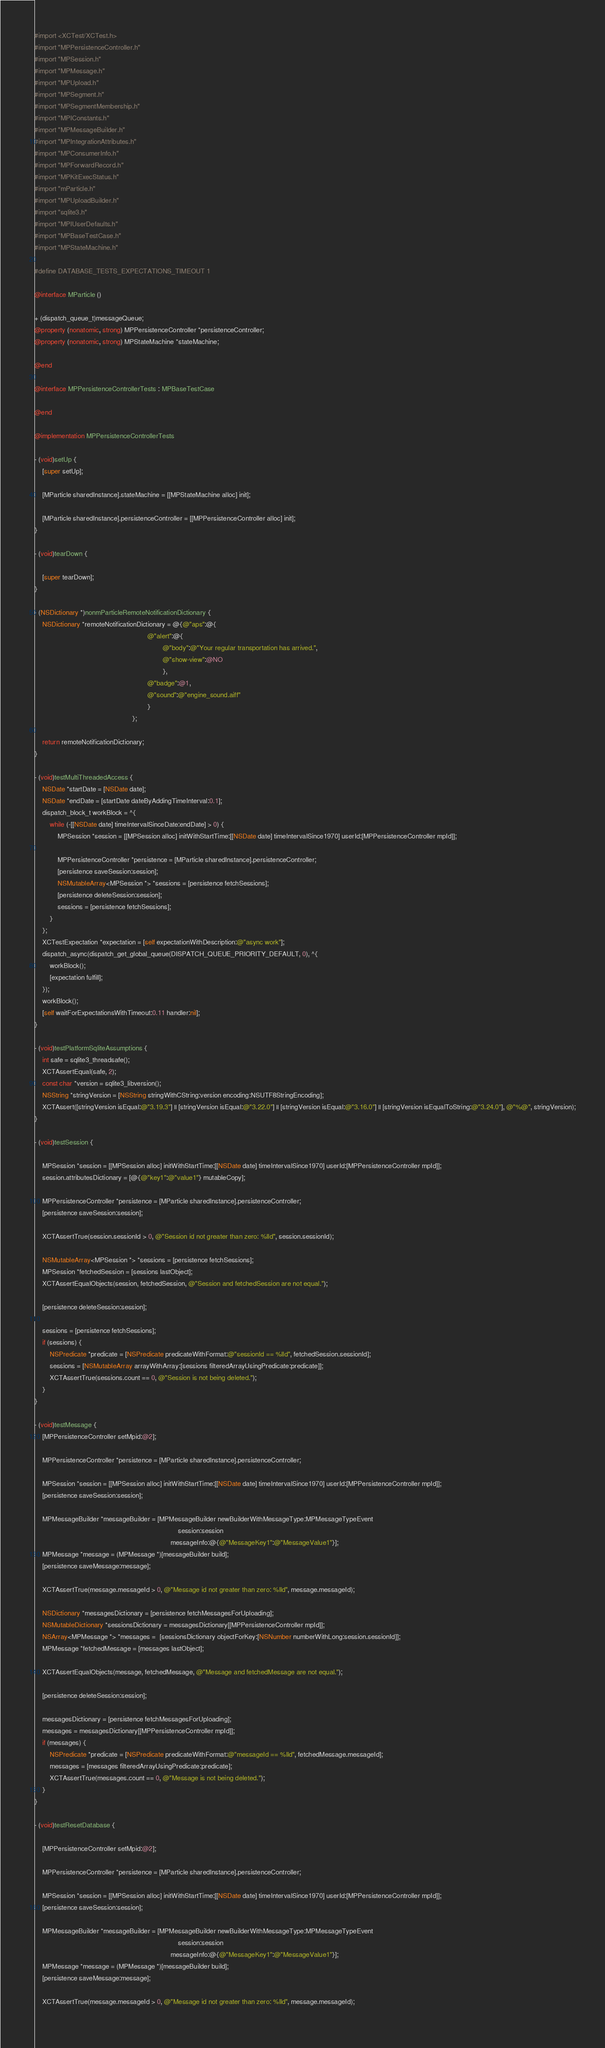Convert code to text. <code><loc_0><loc_0><loc_500><loc_500><_ObjectiveC_>#import <XCTest/XCTest.h>
#import "MPPersistenceController.h"
#import "MPSession.h"
#import "MPMessage.h"
#import "MPUpload.h"
#import "MPSegment.h"
#import "MPSegmentMembership.h"
#import "MPIConstants.h"
#import "MPMessageBuilder.h"
#import "MPIntegrationAttributes.h"
#import "MPConsumerInfo.h"
#import "MPForwardRecord.h"
#import "MPKitExecStatus.h"
#import "mParticle.h"
#import "MPUploadBuilder.h"
#import "sqlite3.h"
#import "MPIUserDefaults.h"
#import "MPBaseTestCase.h"
#import "MPStateMachine.h"

#define DATABASE_TESTS_EXPECTATIONS_TIMEOUT 1

@interface MParticle ()

+ (dispatch_queue_t)messageQueue;
@property (nonatomic, strong) MPPersistenceController *persistenceController;
@property (nonatomic, strong) MPStateMachine *stateMachine;

@end

@interface MPPersistenceControllerTests : MPBaseTestCase

@end

@implementation MPPersistenceControllerTests

- (void)setUp {
    [super setUp];
    
    [MParticle sharedInstance].stateMachine = [[MPStateMachine alloc] init];

    [MParticle sharedInstance].persistenceController = [[MPPersistenceController alloc] init];
}

- (void)tearDown {
    
    [super tearDown];
}

- (NSDictionary *)nonmParticleRemoteNotificationDictionary {
    NSDictionary *remoteNotificationDictionary = @{@"aps":@{
                                                           @"alert":@{
                                                                   @"body":@"Your regular transportation has arrived.",
                                                                   @"show-view":@NO
                                                                   },
                                                           @"badge":@1,
                                                           @"sound":@"engine_sound.aiff"
                                                           }
                                                   };
    
    return remoteNotificationDictionary;
}

- (void)testMultiThreadedAccess {
    NSDate *startDate = [NSDate date];
    NSDate *endDate = [startDate dateByAddingTimeInterval:0.1];
    dispatch_block_t workBlock = ^{
        while (-[[NSDate date] timeIntervalSinceDate:endDate] > 0) {
            MPSession *session = [[MPSession alloc] initWithStartTime:[[NSDate date] timeIntervalSince1970] userId:[MPPersistenceController mpId]];
            
            MPPersistenceController *persistence = [MParticle sharedInstance].persistenceController;
            [persistence saveSession:session];
            NSMutableArray<MPSession *> *sessions = [persistence fetchSessions];
            [persistence deleteSession:session];
            sessions = [persistence fetchSessions];
        }
    };
    XCTestExpectation *expectation = [self expectationWithDescription:@"async work"];
    dispatch_async(dispatch_get_global_queue(DISPATCH_QUEUE_PRIORITY_DEFAULT, 0), ^{
        workBlock();
        [expectation fulfill];
    });
    workBlock();
    [self waitForExpectationsWithTimeout:0.11 handler:nil];
}

- (void)testPlatformSqliteAssumptions {
    int safe = sqlite3_threadsafe();
    XCTAssertEqual(safe, 2);
    const char *version = sqlite3_libversion();
    NSString *stringVersion = [NSString stringWithCString:version encoding:NSUTF8StringEncoding];
    XCTAssert([stringVersion isEqual:@"3.19.3"] || [stringVersion isEqual:@"3.22.0"] || [stringVersion isEqual:@"3.16.0"] || [stringVersion isEqualToString:@"3.24.0"], @"%@", stringVersion);
}

- (void)testSession {
    
    MPSession *session = [[MPSession alloc] initWithStartTime:[[NSDate date] timeIntervalSince1970] userId:[MPPersistenceController mpId]];
    session.attributesDictionary = [@{@"key1":@"value1"} mutableCopy];
    
    MPPersistenceController *persistence = [MParticle sharedInstance].persistenceController;
    [persistence saveSession:session];
    
    XCTAssertTrue(session.sessionId > 0, @"Session id not greater than zero: %lld", session.sessionId);
    
    NSMutableArray<MPSession *> *sessions = [persistence fetchSessions];
    MPSession *fetchedSession = [sessions lastObject];
    XCTAssertEqualObjects(session, fetchedSession, @"Session and fetchedSession are not equal.");
    
    [persistence deleteSession:session];
    
    sessions = [persistence fetchSessions];
    if (sessions) {
        NSPredicate *predicate = [NSPredicate predicateWithFormat:@"sessionId == %lld", fetchedSession.sessionId];
        sessions = [NSMutableArray arrayWithArray:[sessions filteredArrayUsingPredicate:predicate]];
        XCTAssertTrue(sessions.count == 0, @"Session is not being deleted.");
    }
}

- (void)testMessage {
    [MPPersistenceController setMpid:@2];
    
    MPPersistenceController *persistence = [MParticle sharedInstance].persistenceController;
    
    MPSession *session = [[MPSession alloc] initWithStartTime:[[NSDate date] timeIntervalSince1970] userId:[MPPersistenceController mpId]];
    [persistence saveSession:session];
    
    MPMessageBuilder *messageBuilder = [MPMessageBuilder newBuilderWithMessageType:MPMessageTypeEvent
                                                                           session:session
                                                                       messageInfo:@{@"MessageKey1":@"MessageValue1"}];
    MPMessage *message = (MPMessage *)[messageBuilder build];
    [persistence saveMessage:message];
    
    XCTAssertTrue(message.messageId > 0, @"Message id not greater than zero: %lld", message.messageId);
    
    NSDictionary *messagesDictionary = [persistence fetchMessagesForUploading];
    NSMutableDictionary *sessionsDictionary = messagesDictionary[[MPPersistenceController mpId]];
    NSArray<MPMessage *> *messages =  [sessionsDictionary objectForKey:[NSNumber numberWithLong:session.sessionId]];
    MPMessage *fetchedMessage = [messages lastObject];
    
    XCTAssertEqualObjects(message, fetchedMessage, @"Message and fetchedMessage are not equal.");
    
    [persistence deleteSession:session];
    
    messagesDictionary = [persistence fetchMessagesForUploading];
    messages = messagesDictionary[[MPPersistenceController mpId]];
    if (messages) {
        NSPredicate *predicate = [NSPredicate predicateWithFormat:@"messageId == %lld", fetchedMessage.messageId];
        messages = [messages filteredArrayUsingPredicate:predicate];
        XCTAssertTrue(messages.count == 0, @"Message is not being deleted.");
    }
}

- (void)testResetDatabase {
    
    [MPPersistenceController setMpid:@2];
    
    MPPersistenceController *persistence = [MParticle sharedInstance].persistenceController;
    
    MPSession *session = [[MPSession alloc] initWithStartTime:[[NSDate date] timeIntervalSince1970] userId:[MPPersistenceController mpId]];
    [persistence saveSession:session];
    
    MPMessageBuilder *messageBuilder = [MPMessageBuilder newBuilderWithMessageType:MPMessageTypeEvent
                                                                           session:session
                                                                       messageInfo:@{@"MessageKey1":@"MessageValue1"}];
    MPMessage *message = (MPMessage *)[messageBuilder build];
    [persistence saveMessage:message];
    
    XCTAssertTrue(message.messageId > 0, @"Message id not greater than zero: %lld", message.messageId);
    </code> 